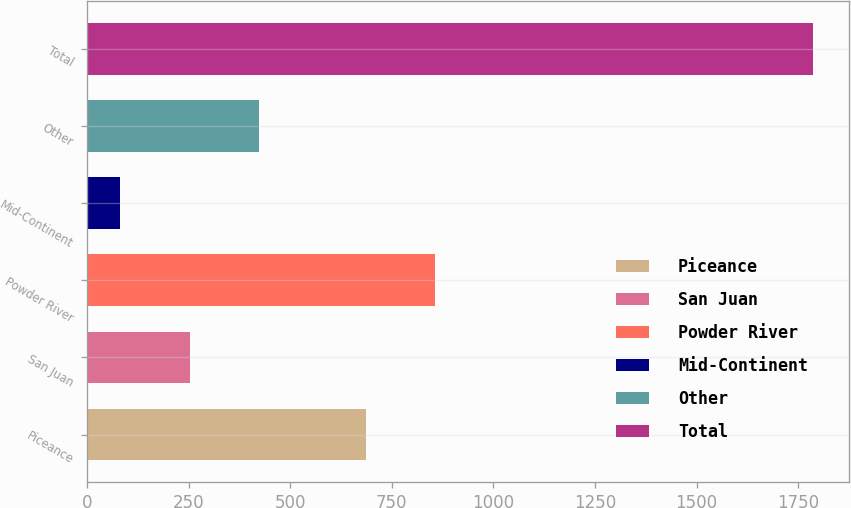Convert chart. <chart><loc_0><loc_0><loc_500><loc_500><bar_chart><fcel>Piceance<fcel>San Juan<fcel>Powder River<fcel>Mid-Continent<fcel>Other<fcel>Total<nl><fcel>687<fcel>252.5<fcel>857.5<fcel>82<fcel>423<fcel>1787<nl></chart> 